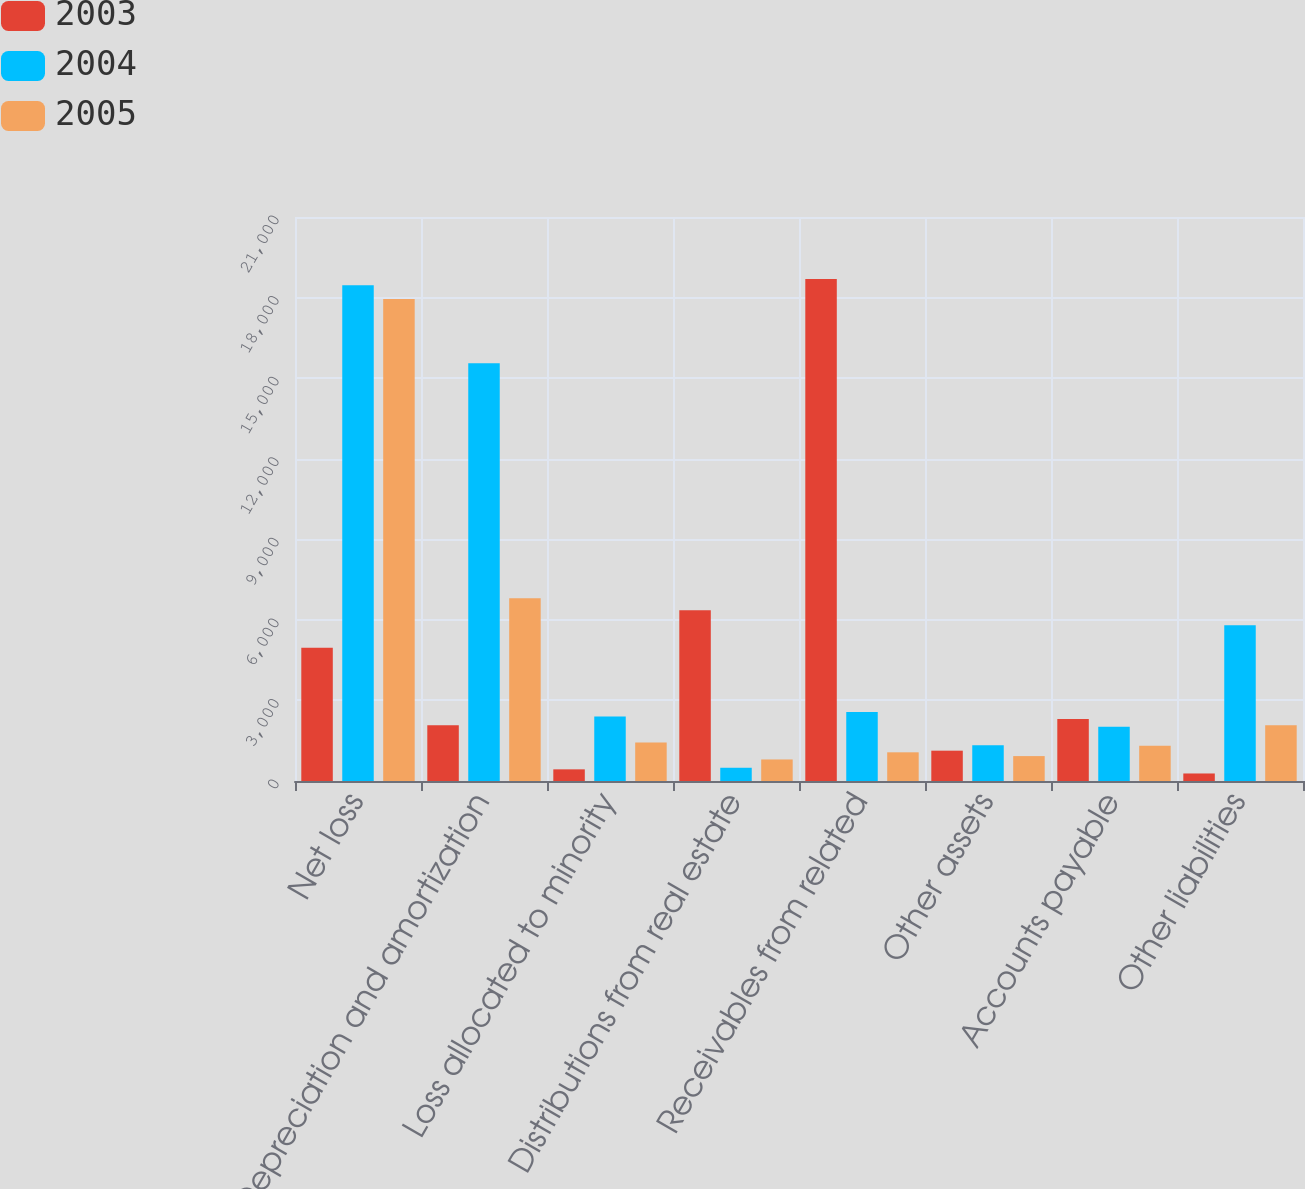<chart> <loc_0><loc_0><loc_500><loc_500><stacked_bar_chart><ecel><fcel>Net loss<fcel>Depreciation and amortization<fcel>Loss allocated to minority<fcel>Distributions from real estate<fcel>Receivables from related<fcel>Other assets<fcel>Accounts payable<fcel>Other liabilities<nl><fcel>2003<fcel>4966<fcel>2074<fcel>434<fcel>6356<fcel>18691<fcel>1129<fcel>2309<fcel>280<nl><fcel>2004<fcel>18462<fcel>15552<fcel>2403<fcel>493<fcel>2573<fcel>1330<fcel>2020<fcel>5795<nl><fcel>2005<fcel>17946<fcel>6805<fcel>1431<fcel>802<fcel>1068<fcel>927<fcel>1312<fcel>2074<nl></chart> 